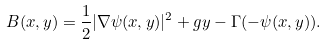<formula> <loc_0><loc_0><loc_500><loc_500>B ( x , y ) = \frac { 1 } { 2 } | \nabla \psi ( x , y ) | ^ { 2 } + g y - \Gamma ( - \psi ( x , y ) ) .</formula> 